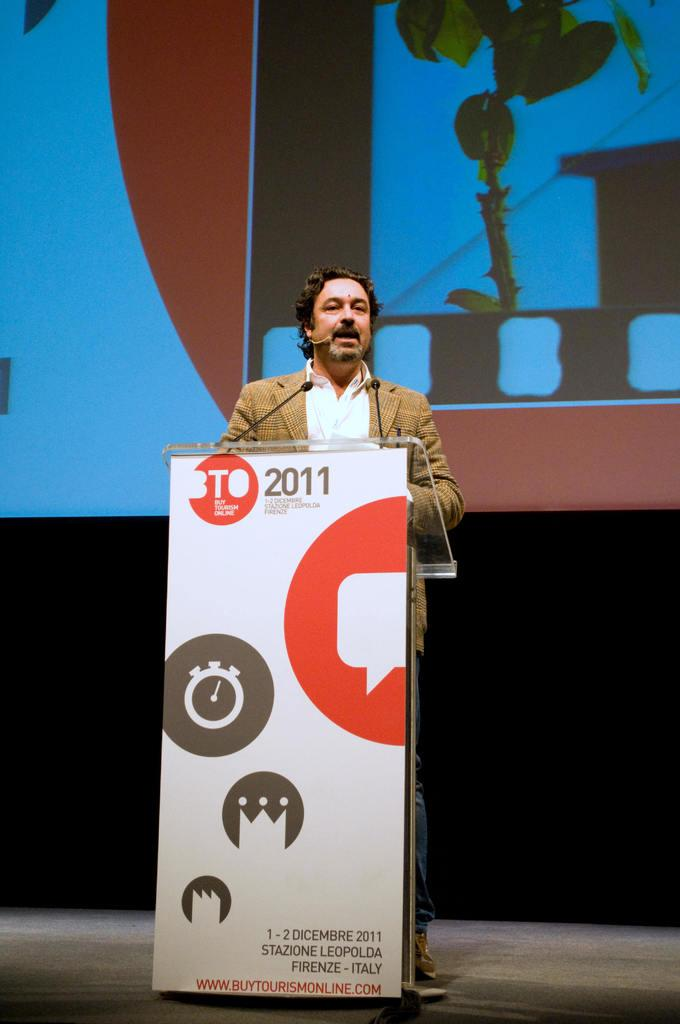<image>
Write a terse but informative summary of the picture. a man at a podium labelled BTO 2011 speaking 